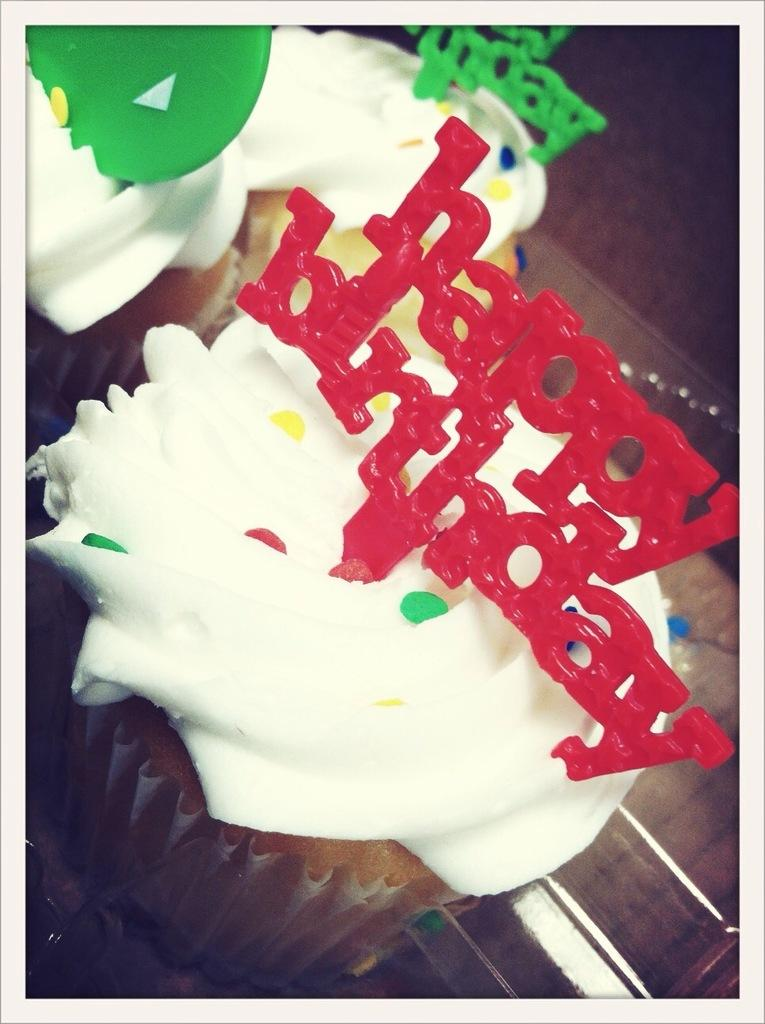What type of dessert can be seen in the image? There are cupcakes in the image. What decorative elements are present on the cupcakes? There are cake toppers in the image. What type of line can be seen connecting the cupcakes in the image? There is no line connecting the cupcakes in the image. What type of iron is used to make the cake toppers in the image? There is no iron present in the image, as the cake toppers are decorative elements and not made of iron. 